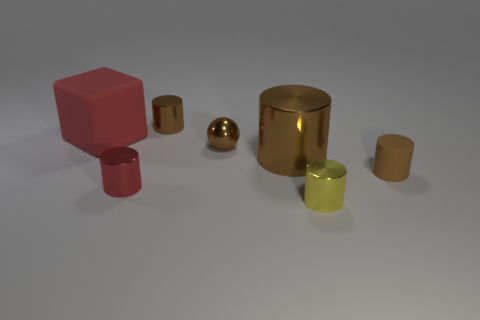What number of blocks are on the left side of the block?
Make the answer very short. 0. There is a brown metallic object behind the tiny brown metallic object right of the tiny metallic object behind the big red cube; what size is it?
Your answer should be compact. Small. Is there a red cube behind the small brown thing on the right side of the tiny thing in front of the red cylinder?
Provide a short and direct response. Yes. Is the number of tiny gray cylinders greater than the number of small brown balls?
Offer a terse response. No. There is a metallic cylinder that is behind the large cube; what is its color?
Offer a terse response. Brown. Is the number of tiny cylinders left of the big brown shiny cylinder greater than the number of small gray metallic objects?
Keep it short and to the point. Yes. Is the yellow thing made of the same material as the sphere?
Provide a short and direct response. Yes. What number of other objects are the same shape as the yellow shiny object?
Give a very brief answer. 4. There is a tiny metal thing to the left of the tiny brown cylinder that is left of the tiny thing that is on the right side of the yellow metallic object; what color is it?
Your response must be concise. Red. There is a brown thing left of the metallic sphere; is it the same shape as the brown rubber thing?
Make the answer very short. Yes. 